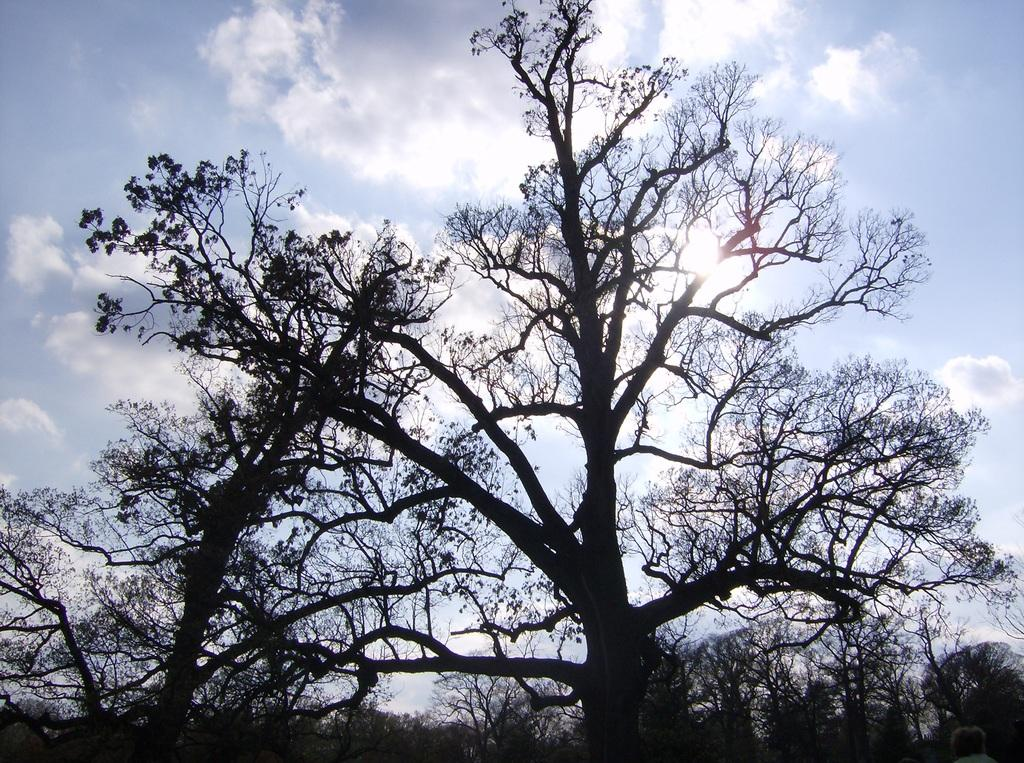What type of vegetation is present in the image? There are trees with leaves in the image. What is visible in the background of the image? The sky is visible in the background of the image. What can be seen in the sky in the image? There are clouds in the sky. What type of meat is being grilled in the image? There is no meat or grilling apparatus present in the image. 